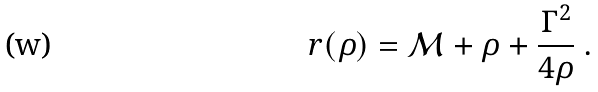<formula> <loc_0><loc_0><loc_500><loc_500>r ( \rho ) = { \mathcal { M } } + \rho + \frac { \Gamma ^ { 2 } } { 4 \rho } \ .</formula> 